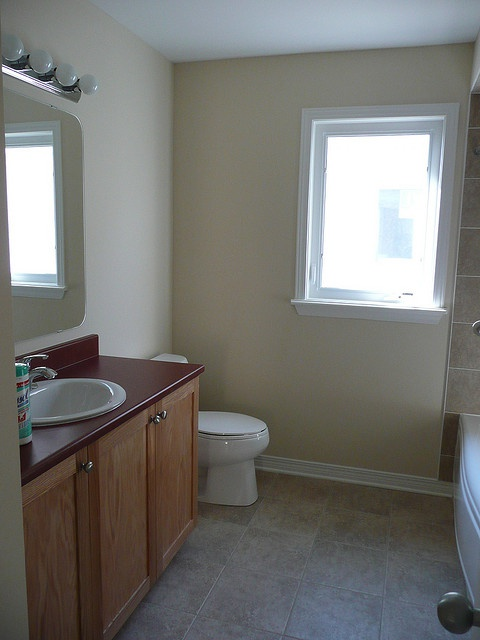Describe the objects in this image and their specific colors. I can see sink in gray and black tones and toilet in gray and black tones in this image. 